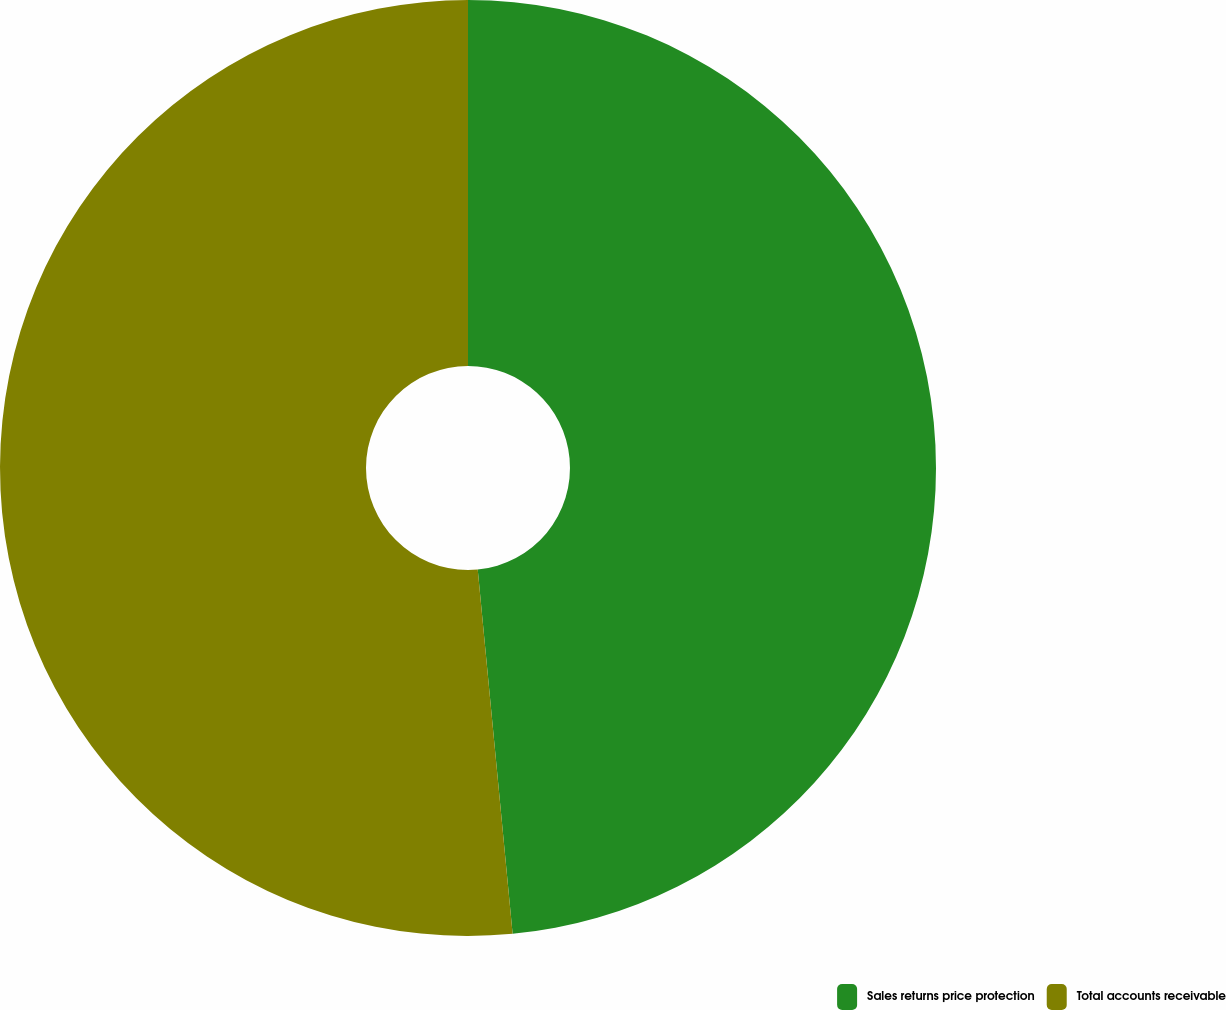<chart> <loc_0><loc_0><loc_500><loc_500><pie_chart><fcel>Sales returns price protection<fcel>Total accounts receivable<nl><fcel>48.48%<fcel>51.52%<nl></chart> 